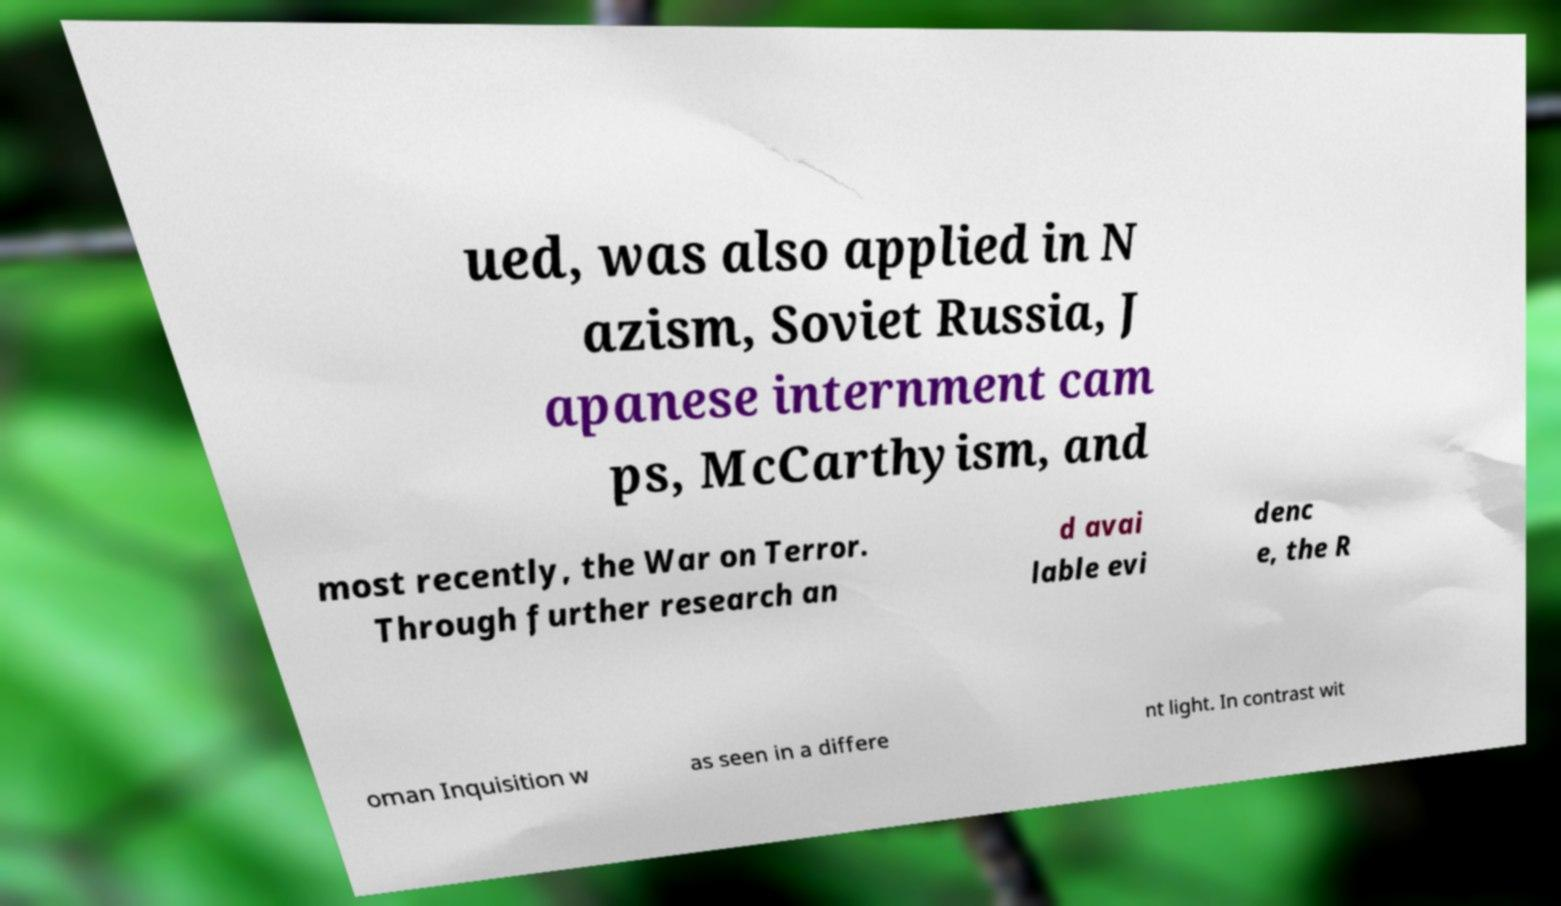Could you assist in decoding the text presented in this image and type it out clearly? ued, was also applied in N azism, Soviet Russia, J apanese internment cam ps, McCarthyism, and most recently, the War on Terror. Through further research an d avai lable evi denc e, the R oman Inquisition w as seen in a differe nt light. In contrast wit 